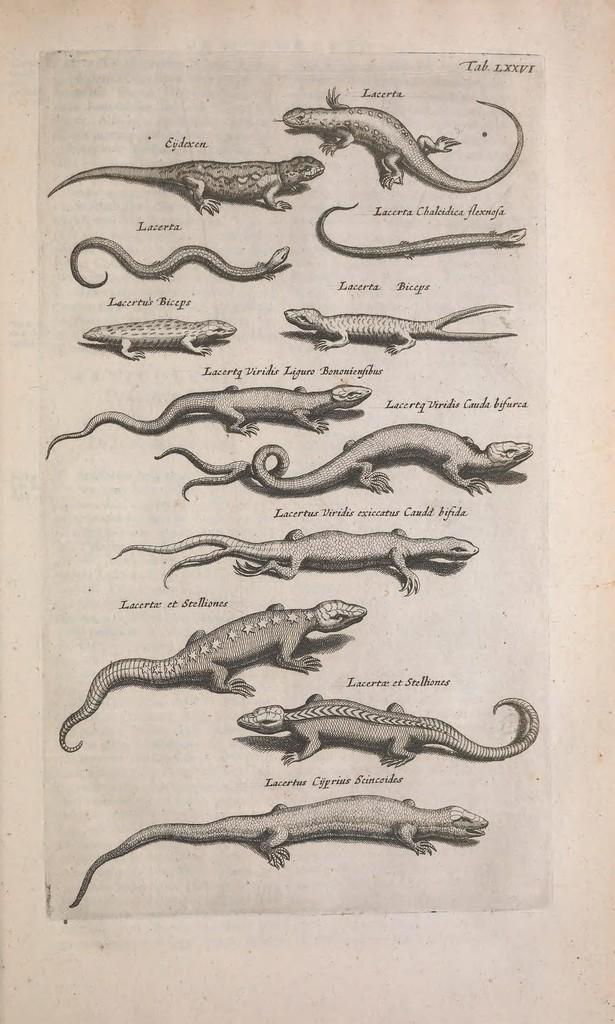What is depicted on the paper in the image? The paper contains images of different animals. How are the animal images organized on the paper? Each animal image has a corresponding name on the paper. What type of oil is used to create the images on the paper? There is no mention of oil being used to create the images on the paper, and therefore it cannot be determined from the image. 